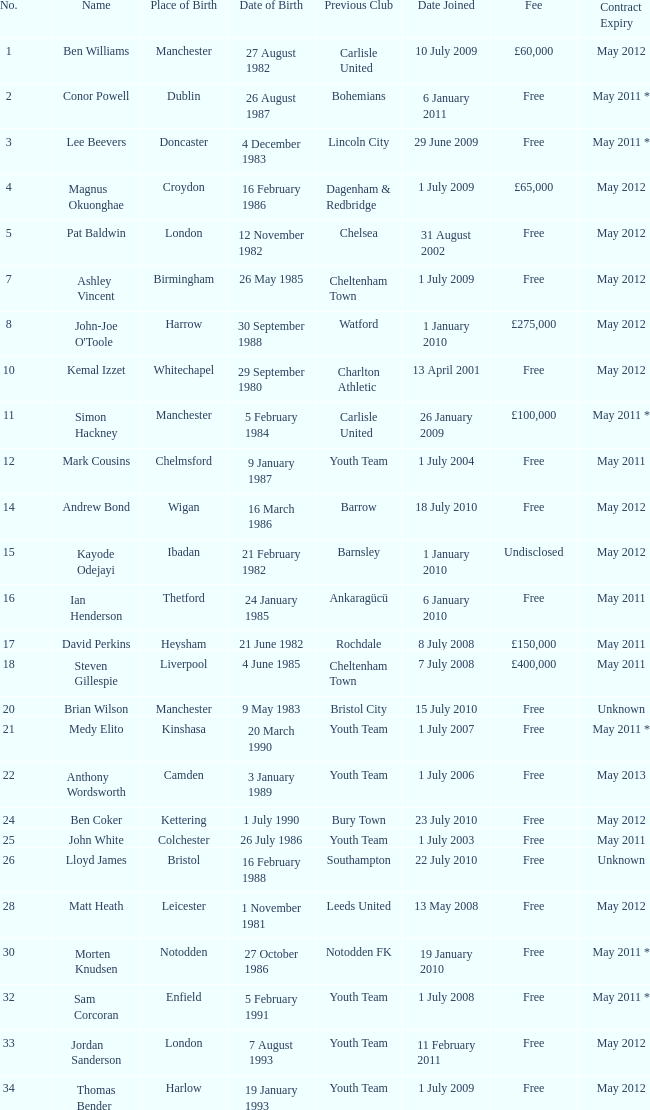Regarding the 7th, when is the date of birth? 26 May 1985. 